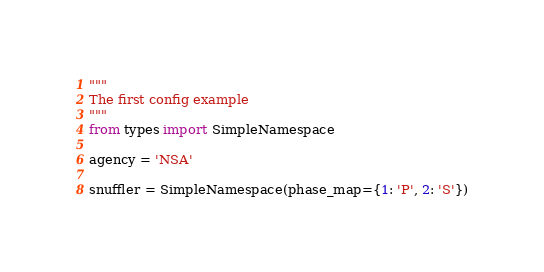Convert code to text. <code><loc_0><loc_0><loc_500><loc_500><_Python_>"""
The first config example
"""
from types import SimpleNamespace

agency = 'NSA'

snuffler = SimpleNamespace(phase_map={1: 'P', 2: 'S'})

</code> 